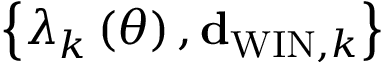Convert formula to latex. <formula><loc_0><loc_0><loc_500><loc_500>\left \{ \lambda _ { k } \left ( \theta \right ) , { d } _ { W I N , k } \right \}</formula> 